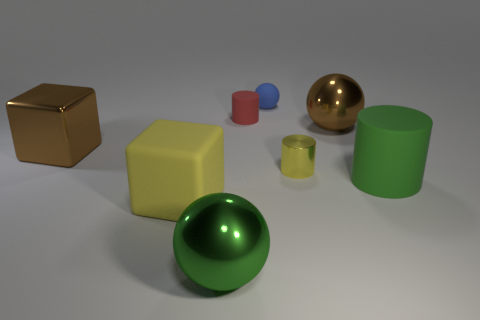Subtract all brown cylinders. Subtract all brown spheres. How many cylinders are left? 3 Add 2 tiny purple rubber cylinders. How many objects exist? 10 Subtract all cylinders. How many objects are left? 5 Subtract all brown metal cubes. Subtract all big brown metallic spheres. How many objects are left? 6 Add 5 small blue matte spheres. How many small blue matte spheres are left? 6 Add 7 small shiny cylinders. How many small shiny cylinders exist? 8 Subtract 0 purple cylinders. How many objects are left? 8 